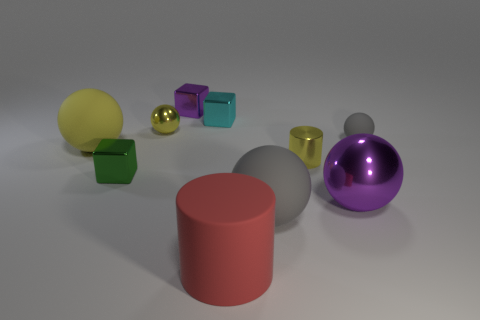Subtract all small purple blocks. How many blocks are left? 2 Subtract all red cubes. How many yellow balls are left? 2 Subtract all cyan cubes. How many cubes are left? 2 Subtract all blocks. How many objects are left? 7 Subtract 3 spheres. How many spheres are left? 2 Add 8 tiny green objects. How many tiny green objects exist? 9 Subtract 0 gray cylinders. How many objects are left? 10 Subtract all brown cylinders. Subtract all red cubes. How many cylinders are left? 2 Subtract all big metal objects. Subtract all small cyan shiny objects. How many objects are left? 8 Add 3 big spheres. How many big spheres are left? 6 